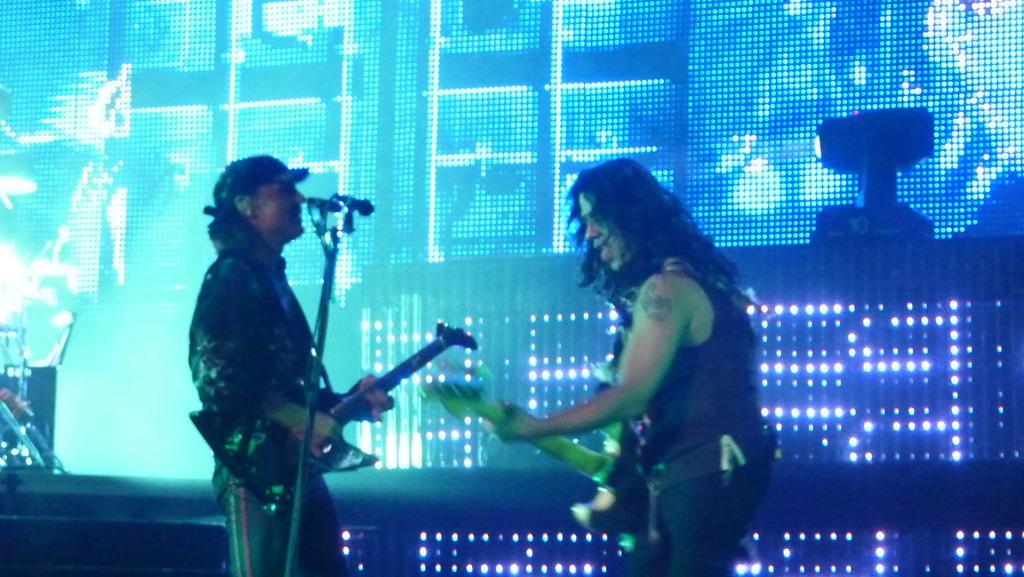Can you describe this image briefly? In this image there are two people playing musical instruments and there is a mike, in the background there is a screen. 